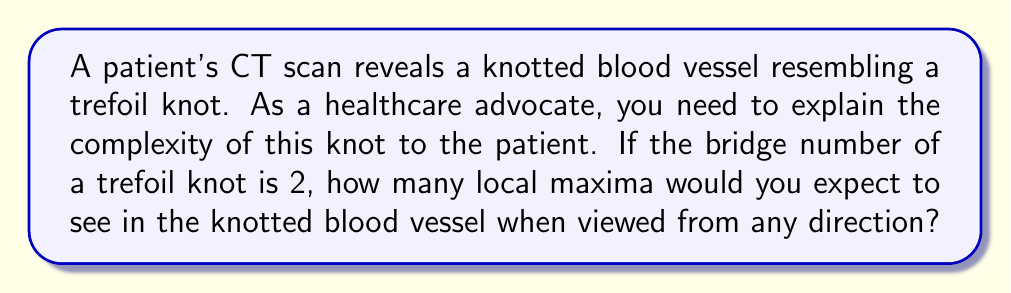Can you answer this question? To answer this question, we need to understand the concept of bridge number and its relation to local maxima in knots:

1. The bridge number of a knot is defined as the minimum number of local maxima (bridges) that the knot must have when projected onto a plane, considering all possible projections.

2. For a trefoil knot, the bridge number is 2, as given in the question.

3. The bridge number represents the minimum number of local maxima in any projection. However, when viewed from any arbitrary direction, we may see more local maxima than the bridge number.

4. In fact, the number of local maxima visible from any direction is always greater than or equal to the bridge number.

5. For a trefoil knot, which is a relatively simple knot, the number of local maxima visible from any direction is actually equal to its bridge number.

6. Therefore, when viewing the knotted blood vessel resembling a trefoil knot from any direction, we would expect to see at least 2 local maxima.

7. It's important to note that while some projections might show more than 2 local maxima, there will always be at least 2 visible from any direction due to the bridge number being 2.
Answer: 2 